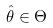<formula> <loc_0><loc_0><loc_500><loc_500>\hat { \theta } \in \Theta</formula> 